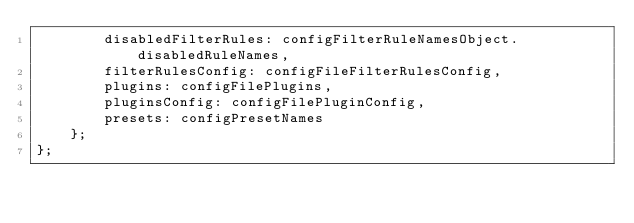Convert code to text. <code><loc_0><loc_0><loc_500><loc_500><_TypeScript_>        disabledFilterRules: configFilterRuleNamesObject.disabledRuleNames,
        filterRulesConfig: configFileFilterRulesConfig,
        plugins: configFilePlugins,
        pluginsConfig: configFilePluginConfig,
        presets: configPresetNames
    };
};
</code> 